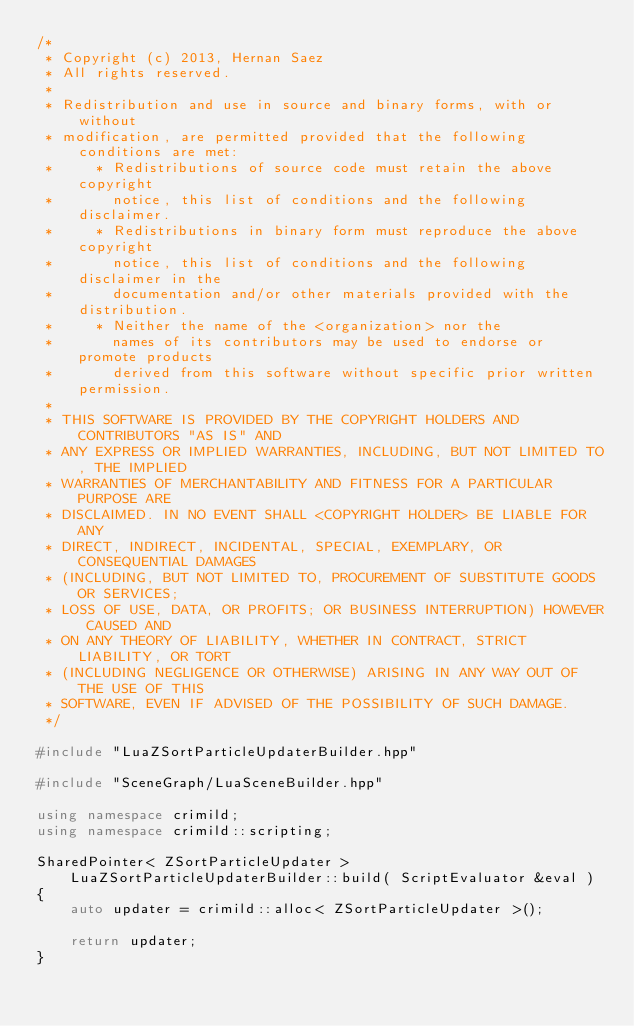<code> <loc_0><loc_0><loc_500><loc_500><_C++_>/*
 * Copyright (c) 2013, Hernan Saez
 * All rights reserved.
 * 
 * Redistribution and use in source and binary forms, with or without
 * modification, are permitted provided that the following conditions are met:
 *     * Redistributions of source code must retain the above copyright
 *       notice, this list of conditions and the following disclaimer.
 *     * Redistributions in binary form must reproduce the above copyright
 *       notice, this list of conditions and the following disclaimer in the
 *       documentation and/or other materials provided with the distribution.
 *     * Neither the name of the <organization> nor the
 *       names of its contributors may be used to endorse or promote products
 *       derived from this software without specific prior written permission.
 * 
 * THIS SOFTWARE IS PROVIDED BY THE COPYRIGHT HOLDERS AND CONTRIBUTORS "AS IS" AND
 * ANY EXPRESS OR IMPLIED WARRANTIES, INCLUDING, BUT NOT LIMITED TO, THE IMPLIED
 * WARRANTIES OF MERCHANTABILITY AND FITNESS FOR A PARTICULAR PURPOSE ARE
 * DISCLAIMED. IN NO EVENT SHALL <COPYRIGHT HOLDER> BE LIABLE FOR ANY
 * DIRECT, INDIRECT, INCIDENTAL, SPECIAL, EXEMPLARY, OR CONSEQUENTIAL DAMAGES
 * (INCLUDING, BUT NOT LIMITED TO, PROCUREMENT OF SUBSTITUTE GOODS OR SERVICES;
 * LOSS OF USE, DATA, OR PROFITS; OR BUSINESS INTERRUPTION) HOWEVER CAUSED AND
 * ON ANY THEORY OF LIABILITY, WHETHER IN CONTRACT, STRICT LIABILITY, OR TORT
 * (INCLUDING NEGLIGENCE OR OTHERWISE) ARISING IN ANY WAY OUT OF THE USE OF THIS
 * SOFTWARE, EVEN IF ADVISED OF THE POSSIBILITY OF SUCH DAMAGE.
 */

#include "LuaZSortParticleUpdaterBuilder.hpp"

#include "SceneGraph/LuaSceneBuilder.hpp"

using namespace crimild;
using namespace crimild::scripting;

SharedPointer< ZSortParticleUpdater > LuaZSortParticleUpdaterBuilder::build( ScriptEvaluator &eval )
{
	auto updater = crimild::alloc< ZSortParticleUpdater >();

	return updater;
}

</code> 